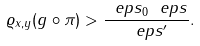Convert formula to latex. <formula><loc_0><loc_0><loc_500><loc_500>\varrho _ { x , y } ( g \circ \pi ) > \frac { \ e p s _ { 0 } \ e p s } { \ e p s ^ { \prime } } .</formula> 